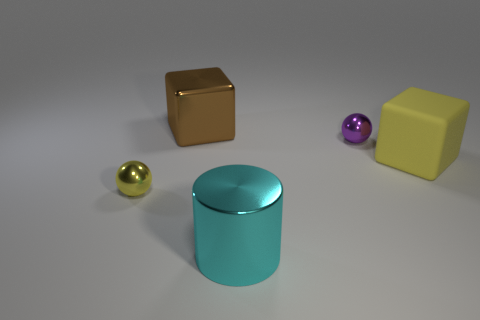What material is the yellow object that is the same shape as the big brown metal object?
Your answer should be compact. Rubber. There is a sphere that is right of the block that is to the left of the big rubber object; what is its size?
Make the answer very short. Small. The metal cylinder is what color?
Make the answer very short. Cyan. What number of big cyan cylinders are behind the block in front of the purple thing?
Keep it short and to the point. 0. Is there a purple metallic object that is to the right of the cube that is in front of the brown cube?
Offer a very short reply. No. There is a yellow matte cube; are there any balls in front of it?
Give a very brief answer. Yes. There is a small metallic thing to the left of the metallic block; does it have the same shape as the purple metal object?
Provide a short and direct response. Yes. What number of brown objects are the same shape as the small purple metal object?
Provide a short and direct response. 0. Are there any small balls that have the same material as the purple thing?
Keep it short and to the point. Yes. What material is the yellow thing behind the small sphere that is to the left of the large metal cylinder made of?
Make the answer very short. Rubber. 